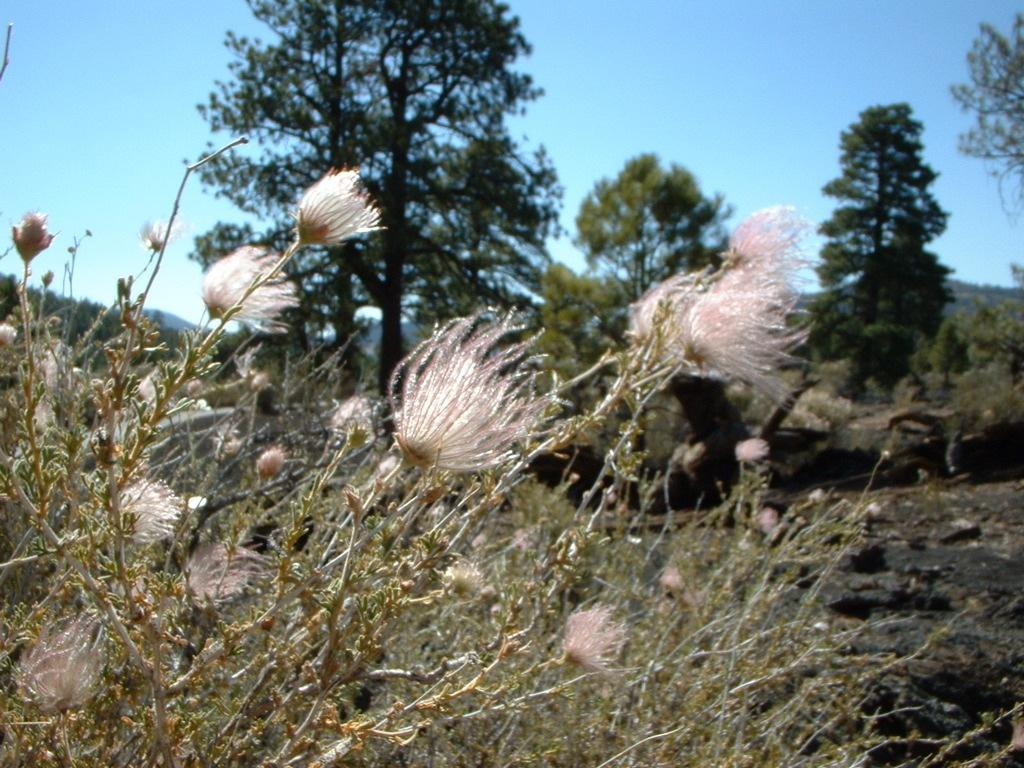What type of plants are present in the image? There are plants with flowers in the image. What can be seen in the background of the image? There are trees, mountains, and the sky visible in the background of the image. What type of gold can be seen in the image? There is no gold present in the image. Are there any poisonous plants visible in the image? There is no information about the plants being poisonous in the image. 